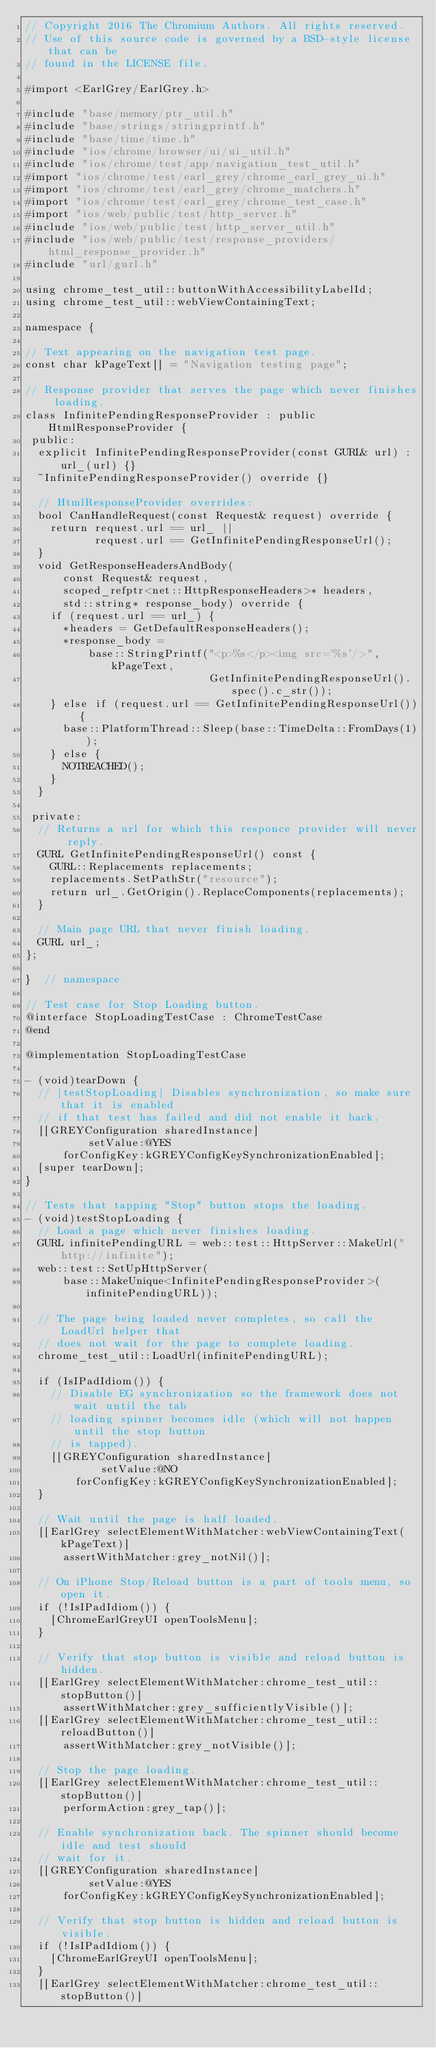Convert code to text. <code><loc_0><loc_0><loc_500><loc_500><_ObjectiveC_>// Copyright 2016 The Chromium Authors. All rights reserved.
// Use of this source code is governed by a BSD-style license that can be
// found in the LICENSE file.

#import <EarlGrey/EarlGrey.h>

#include "base/memory/ptr_util.h"
#include "base/strings/stringprintf.h"
#include "base/time/time.h"
#include "ios/chrome/browser/ui/ui_util.h"
#include "ios/chrome/test/app/navigation_test_util.h"
#import "ios/chrome/test/earl_grey/chrome_earl_grey_ui.h"
#import "ios/chrome/test/earl_grey/chrome_matchers.h"
#import "ios/chrome/test/earl_grey/chrome_test_case.h"
#import "ios/web/public/test/http_server.h"
#include "ios/web/public/test/http_server_util.h"
#include "ios/web/public/test/response_providers/html_response_provider.h"
#include "url/gurl.h"

using chrome_test_util::buttonWithAccessibilityLabelId;
using chrome_test_util::webViewContainingText;

namespace {

// Text appearing on the navigation test page.
const char kPageText[] = "Navigation testing page";

// Response provider that serves the page which never finishes loading.
class InfinitePendingResponseProvider : public HtmlResponseProvider {
 public:
  explicit InfinitePendingResponseProvider(const GURL& url) : url_(url) {}
  ~InfinitePendingResponseProvider() override {}

  // HtmlResponseProvider overrides:
  bool CanHandleRequest(const Request& request) override {
    return request.url == url_ ||
           request.url == GetInfinitePendingResponseUrl();
  }
  void GetResponseHeadersAndBody(
      const Request& request,
      scoped_refptr<net::HttpResponseHeaders>* headers,
      std::string* response_body) override {
    if (request.url == url_) {
      *headers = GetDefaultResponseHeaders();
      *response_body =
          base::StringPrintf("<p>%s</p><img src='%s'/>", kPageText,
                             GetInfinitePendingResponseUrl().spec().c_str());
    } else if (request.url == GetInfinitePendingResponseUrl()) {
      base::PlatformThread::Sleep(base::TimeDelta::FromDays(1));
    } else {
      NOTREACHED();
    }
  }

 private:
  // Returns a url for which this responce provider will never reply.
  GURL GetInfinitePendingResponseUrl() const {
    GURL::Replacements replacements;
    replacements.SetPathStr("resource");
    return url_.GetOrigin().ReplaceComponents(replacements);
  }

  // Main page URL that never finish loading.
  GURL url_;
};

}  // namespace

// Test case for Stop Loading button.
@interface StopLoadingTestCase : ChromeTestCase
@end

@implementation StopLoadingTestCase

- (void)tearDown {
  // |testStopLoading| Disables synchronization, so make sure that it is enabled
  // if that test has failed and did not enable it back.
  [[GREYConfiguration sharedInstance]
          setValue:@YES
      forConfigKey:kGREYConfigKeySynchronizationEnabled];
  [super tearDown];
}

// Tests that tapping "Stop" button stops the loading.
- (void)testStopLoading {
  // Load a page which never finishes loading.
  GURL infinitePendingURL = web::test::HttpServer::MakeUrl("http://infinite");
  web::test::SetUpHttpServer(
      base::MakeUnique<InfinitePendingResponseProvider>(infinitePendingURL));

  // The page being loaded never completes, so call the LoadUrl helper that
  // does not wait for the page to complete loading.
  chrome_test_util::LoadUrl(infinitePendingURL);

  if (IsIPadIdiom()) {
    // Disable EG synchronization so the framework does not wait until the tab
    // loading spinner becomes idle (which will not happen until the stop button
    // is tapped).
    [[GREYConfiguration sharedInstance]
            setValue:@NO
        forConfigKey:kGREYConfigKeySynchronizationEnabled];
  }

  // Wait until the page is half loaded.
  [[EarlGrey selectElementWithMatcher:webViewContainingText(kPageText)]
      assertWithMatcher:grey_notNil()];

  // On iPhone Stop/Reload button is a part of tools menu, so open it.
  if (!IsIPadIdiom()) {
    [ChromeEarlGreyUI openToolsMenu];
  }

  // Verify that stop button is visible and reload button is hidden.
  [[EarlGrey selectElementWithMatcher:chrome_test_util::stopButton()]
      assertWithMatcher:grey_sufficientlyVisible()];
  [[EarlGrey selectElementWithMatcher:chrome_test_util::reloadButton()]
      assertWithMatcher:grey_notVisible()];

  // Stop the page loading.
  [[EarlGrey selectElementWithMatcher:chrome_test_util::stopButton()]
      performAction:grey_tap()];

  // Enable synchronization back. The spinner should become idle and test should
  // wait for it.
  [[GREYConfiguration sharedInstance]
          setValue:@YES
      forConfigKey:kGREYConfigKeySynchronizationEnabled];

  // Verify that stop button is hidden and reload button is visible.
  if (!IsIPadIdiom()) {
    [ChromeEarlGreyUI openToolsMenu];
  }
  [[EarlGrey selectElementWithMatcher:chrome_test_util::stopButton()]</code> 